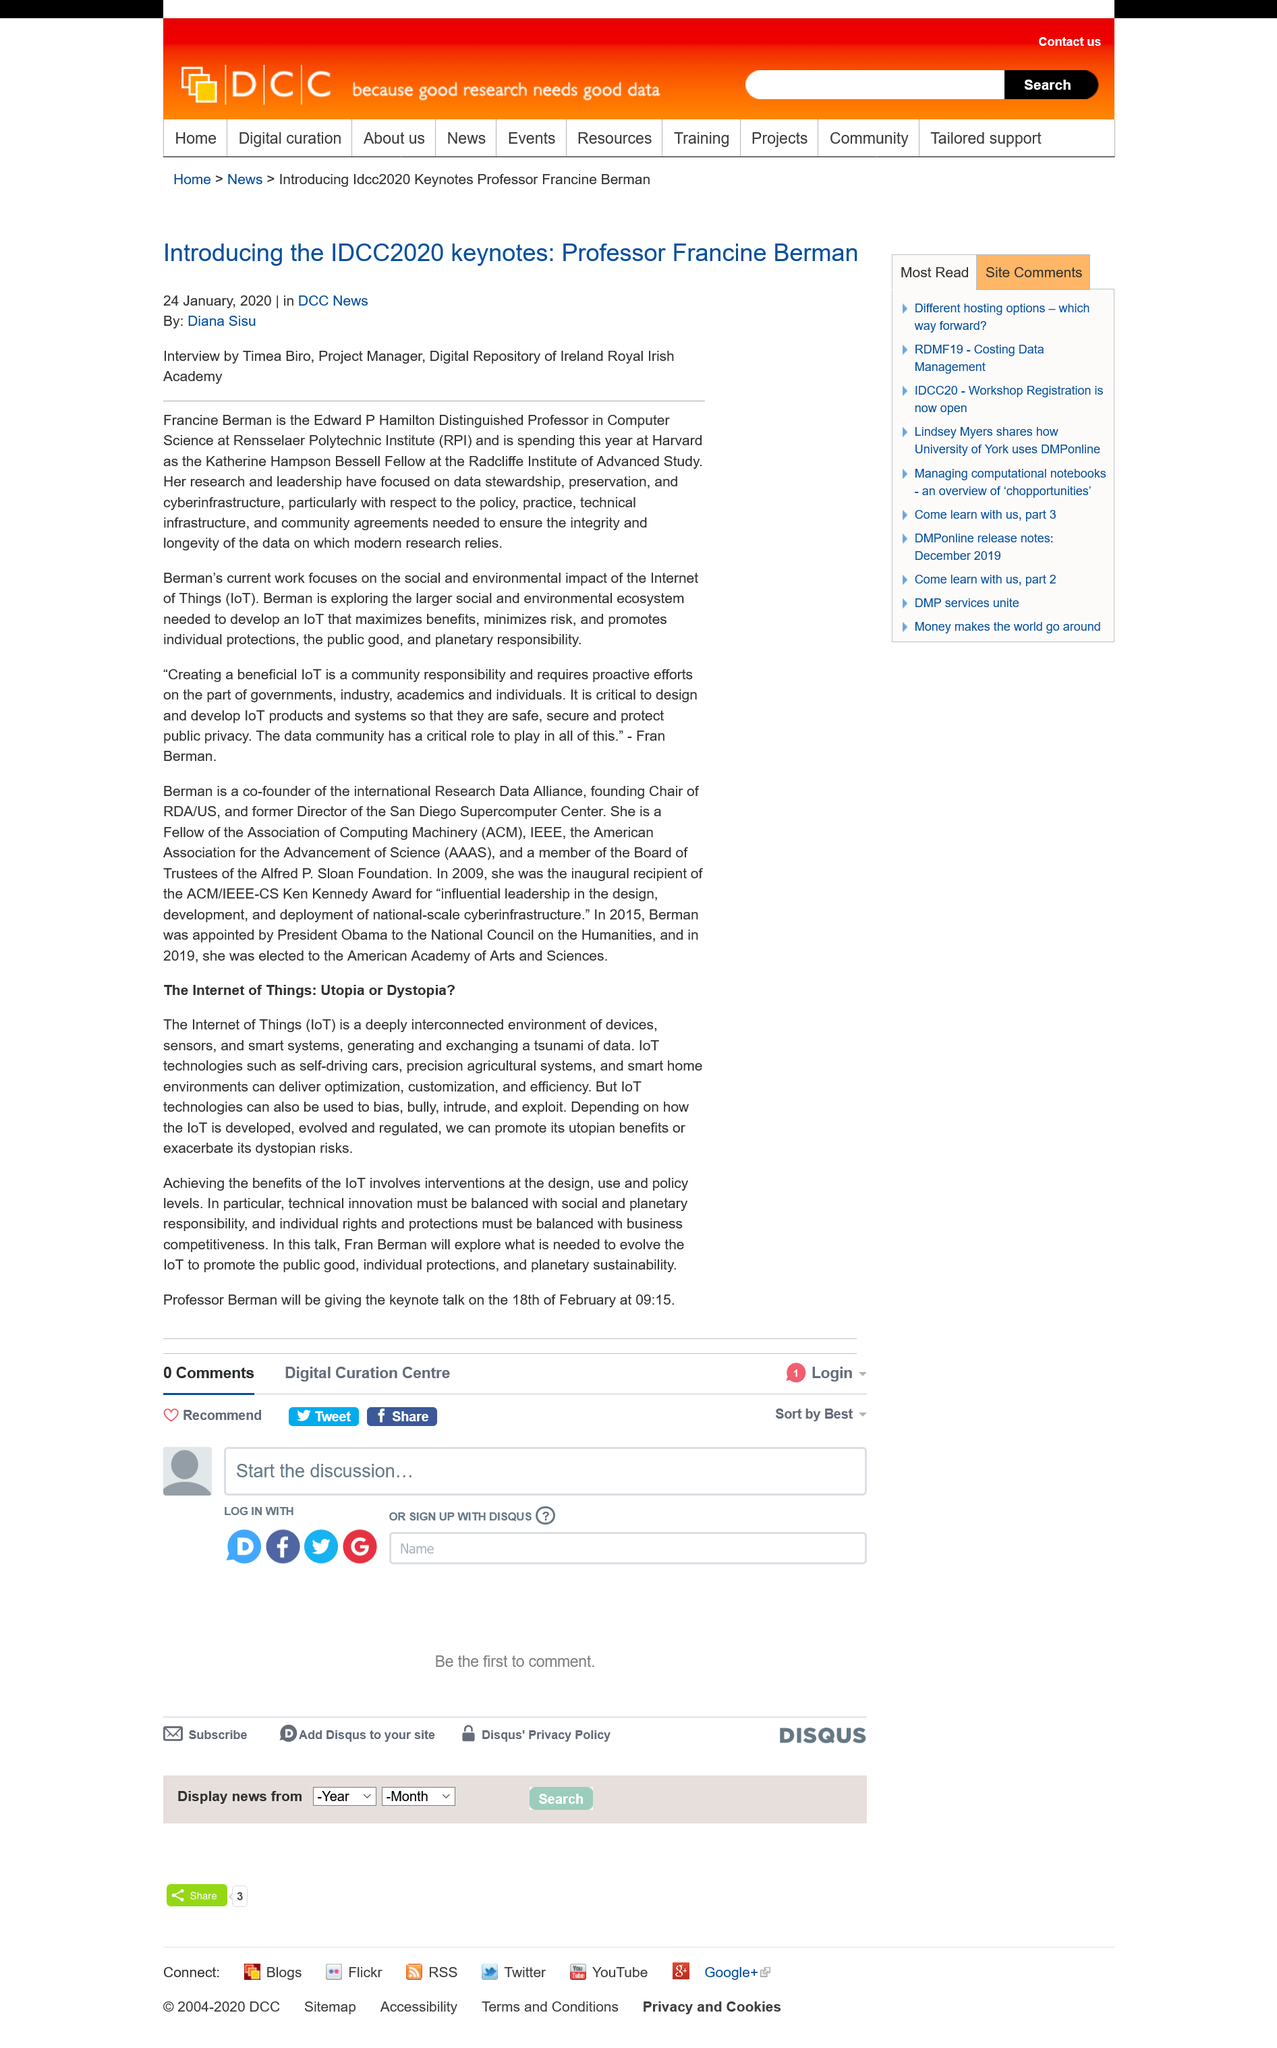List a handful of essential elements in this visual. Francine Berman, a renowned Professor, is the keynote speaker for the IDCC2020 conference. The article by Diana Sisu was published on 24 January, 2020. The negative uses of IoT technologies, such as bias, bullying, intrusion, and exploitation, pose a significant threat to the safety and privacy of individuals. IoT technologies, including self-driving cars, are examples of vehicles that are integrated with internet connectivity and sensors to enable real-time data collection and analysis. These vehicles are equipped with various technologies such as GPS, sensors, and communication systems, which allow them to communicate with each other, the infrastructure, and the cloud. By doing so, they can collect real-time data on traffic, weather, and road conditions, and use this information to make decisions and adjust their behavior accordingly. This enables vehicles to operate autonomously, reducing the risk of accidents and improving traffic flow. The Internet of Things is a vast and interconnected network of devices, sensors, and smart systems that generate and exchange a vast amount of data, fundamentally changing the way people interact with technology and their surroundings. 